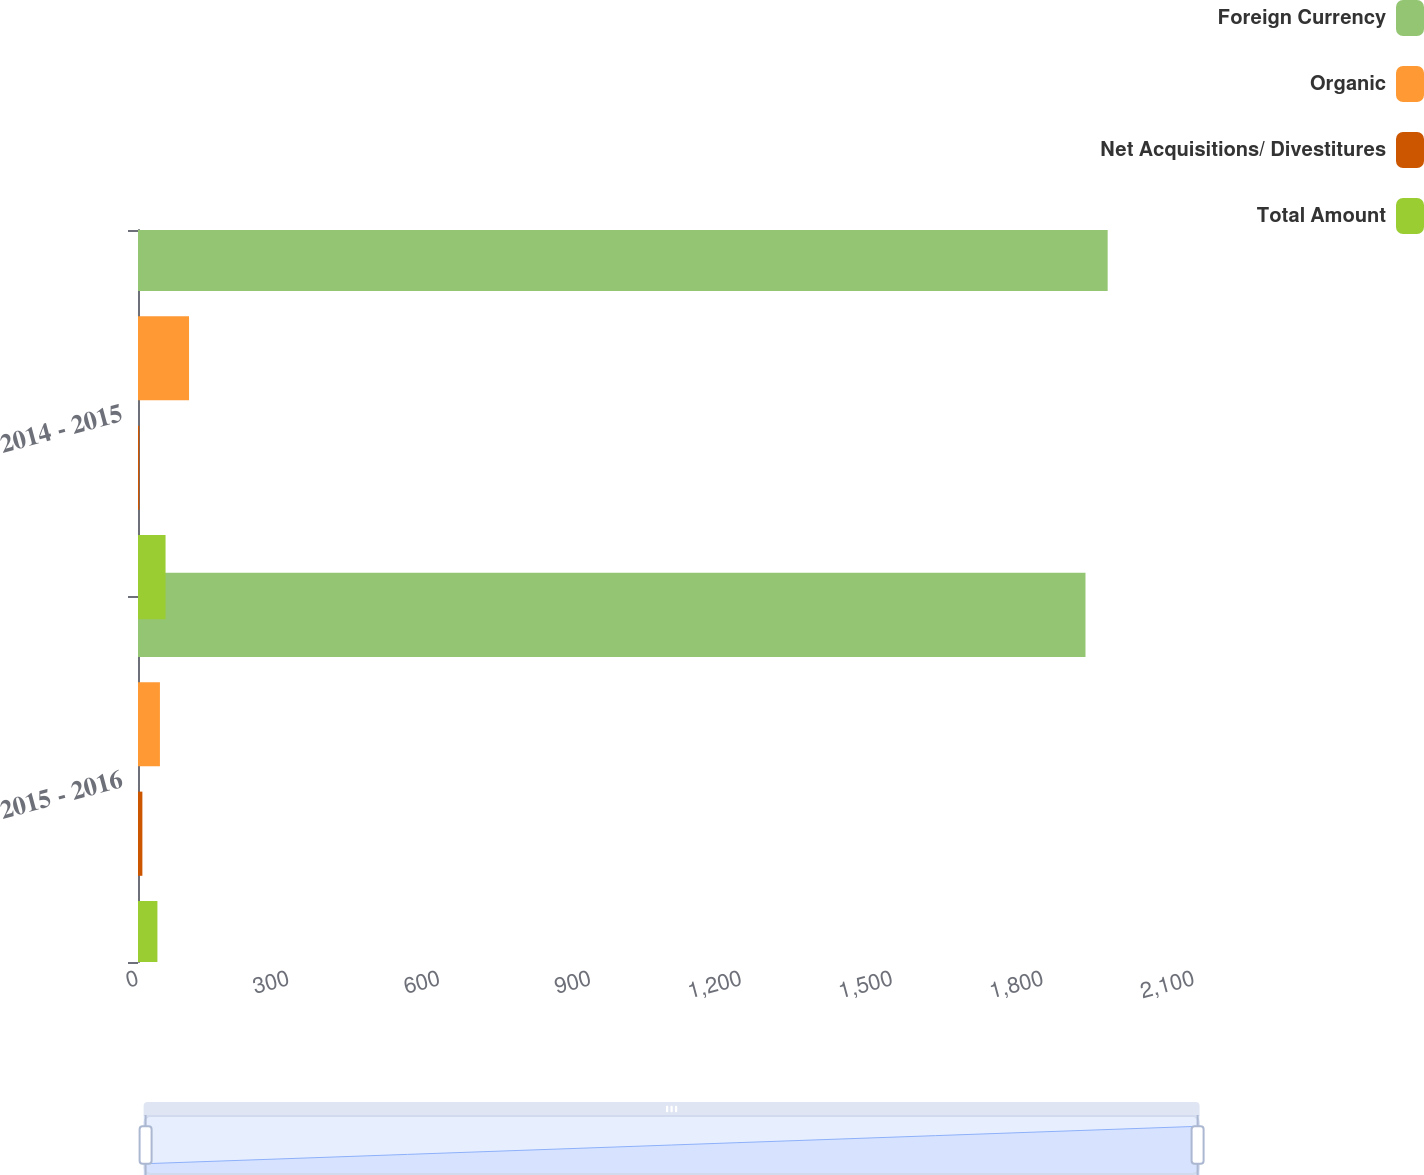Convert chart to OTSL. <chart><loc_0><loc_0><loc_500><loc_500><stacked_bar_chart><ecel><fcel>2015 - 2016<fcel>2014 - 2015<nl><fcel>Foreign Currency<fcel>1884.2<fcel>1928.3<nl><fcel>Organic<fcel>43.6<fcel>101.5<nl><fcel>Net Acquisitions/ Divestitures<fcel>8.7<fcel>2.6<nl><fcel>Total Amount<fcel>38.6<fcel>54.8<nl></chart> 